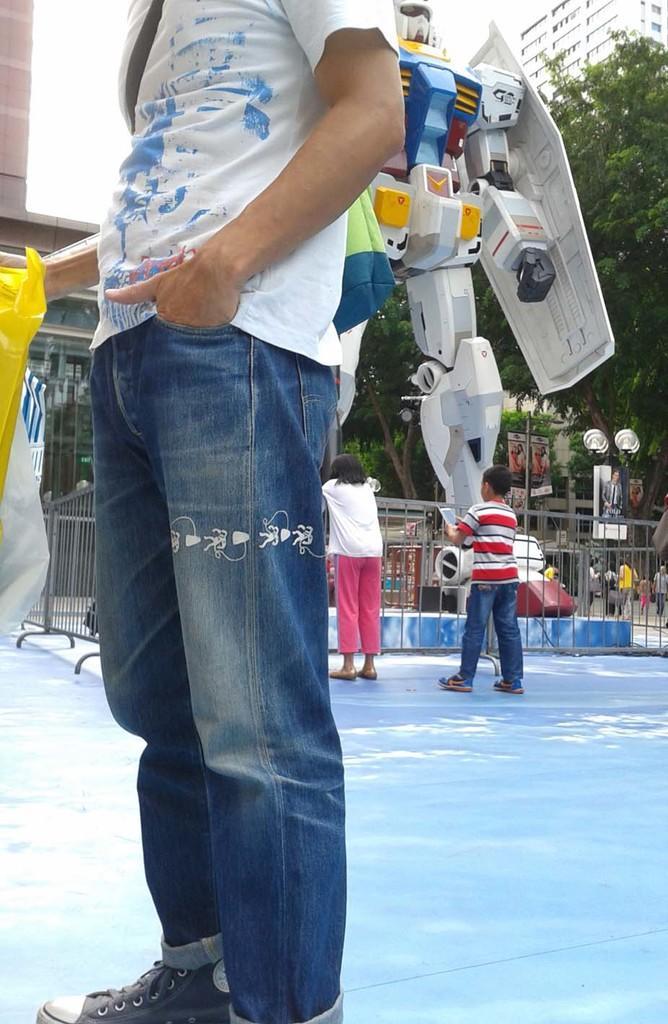Could you give a brief overview of what you see in this image? This picture describes about group of people, in the middle of the image we can see a robot, in front of the robot we can find fence, in the background we can see trees and buildings. 